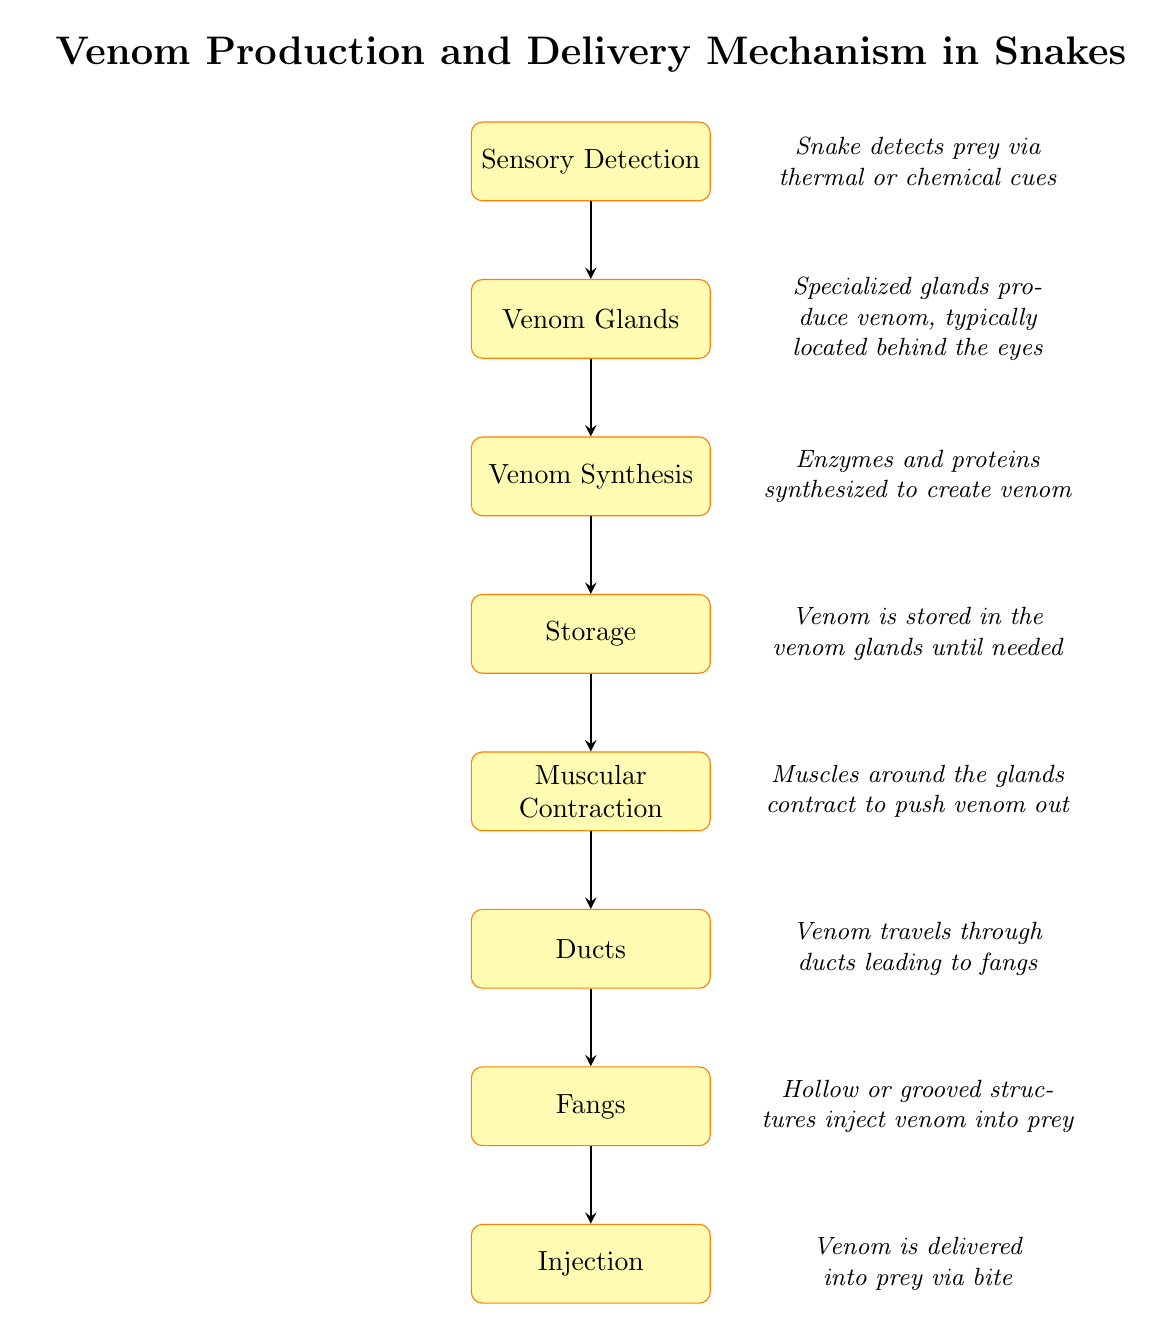What is the first step in the process? The first step is labeled 'Sensory Detection' in the flow chart, indicating how the snake detects its prey.
Answer: Sensory Detection How many nodes are in the flow chart? The flow chart contains a total of eight nodes, each representing a specific step in the venom production and delivery mechanism.
Answer: 8 What is stored in the venom glands? The section labeled 'Storage' indicates that venom is stored in the venom glands until it is needed for injection into prey.
Answer: Venom What does the 'Muscular Contraction' node describe? This node describes how muscles around the venom glands contract to push venom out through the ducts.
Answer: Muscles around the glands contract What is the purpose of the 'Ducts' node? The 'Ducts' node indicates the pathway that venom travels through, leading to the fangs for further delivery into prey.
Answer: Venom travels through ducts What needs to happen before venom can be injected? Before venom can be injected, it must first be produced, stored in the glands, and then pushed through the ducts, arriving at the fangs. This involves multiple steps, including synthesis, storage, and muscular contraction to effectively deliver the venom into prey via bite.
Answer: Muscular Contraction, Ducts, Fangs, Injection Which node represents the actual delivery of venom? The last node, labeled 'Injection', represents the step where venom is delivered into the prey.
Answer: Injection What structure is responsible for injecting venom? The 'Fangs' node indicates that these are the structures responsible for injecting venom into the prey, as they are hollow or grooved.
Answer: Fangs 